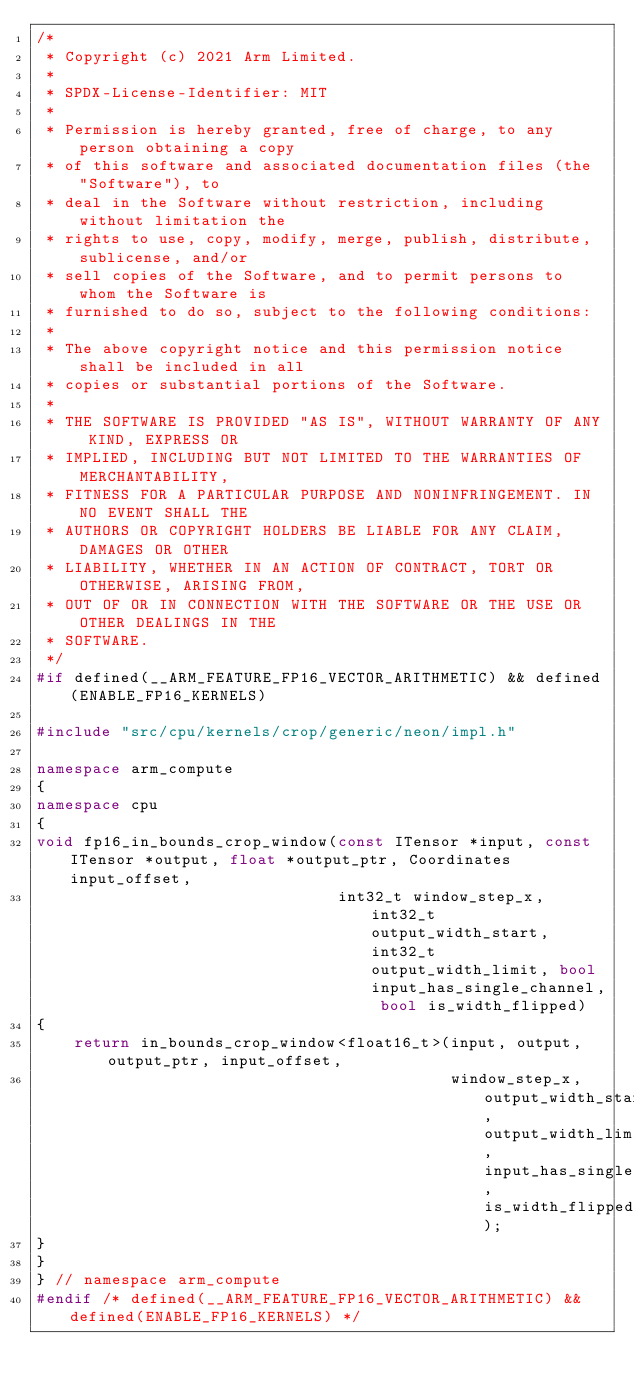<code> <loc_0><loc_0><loc_500><loc_500><_C++_>/*
 * Copyright (c) 2021 Arm Limited.
 *
 * SPDX-License-Identifier: MIT
 *
 * Permission is hereby granted, free of charge, to any person obtaining a copy
 * of this software and associated documentation files (the "Software"), to
 * deal in the Software without restriction, including without limitation the
 * rights to use, copy, modify, merge, publish, distribute, sublicense, and/or
 * sell copies of the Software, and to permit persons to whom the Software is
 * furnished to do so, subject to the following conditions:
 *
 * The above copyright notice and this permission notice shall be included in all
 * copies or substantial portions of the Software.
 *
 * THE SOFTWARE IS PROVIDED "AS IS", WITHOUT WARRANTY OF ANY KIND, EXPRESS OR
 * IMPLIED, INCLUDING BUT NOT LIMITED TO THE WARRANTIES OF MERCHANTABILITY,
 * FITNESS FOR A PARTICULAR PURPOSE AND NONINFRINGEMENT. IN NO EVENT SHALL THE
 * AUTHORS OR COPYRIGHT HOLDERS BE LIABLE FOR ANY CLAIM, DAMAGES OR OTHER
 * LIABILITY, WHETHER IN AN ACTION OF CONTRACT, TORT OR OTHERWISE, ARISING FROM,
 * OUT OF OR IN CONNECTION WITH THE SOFTWARE OR THE USE OR OTHER DEALINGS IN THE
 * SOFTWARE.
 */
#if defined(__ARM_FEATURE_FP16_VECTOR_ARITHMETIC) && defined(ENABLE_FP16_KERNELS)

#include "src/cpu/kernels/crop/generic/neon/impl.h"

namespace arm_compute
{
namespace cpu
{
void fp16_in_bounds_crop_window(const ITensor *input, const ITensor *output, float *output_ptr, Coordinates input_offset,
                                int32_t window_step_x, int32_t output_width_start, int32_t output_width_limit, bool input_has_single_channel, bool is_width_flipped)
{
    return in_bounds_crop_window<float16_t>(input, output, output_ptr, input_offset,
                                            window_step_x, output_width_start, output_width_limit, input_has_single_channel, is_width_flipped);
}
}
} // namespace arm_compute
#endif /* defined(__ARM_FEATURE_FP16_VECTOR_ARITHMETIC) && defined(ENABLE_FP16_KERNELS) */
</code> 